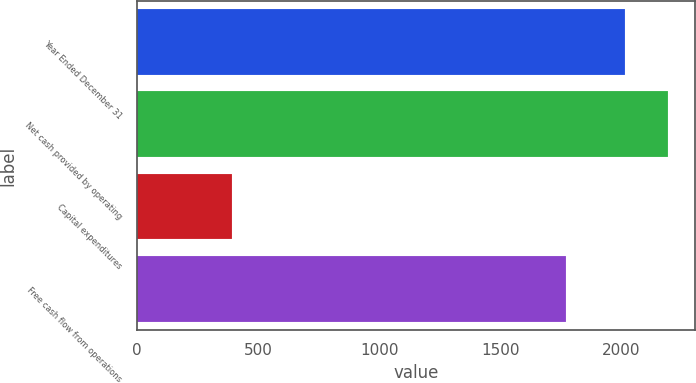<chart> <loc_0><loc_0><loc_500><loc_500><bar_chart><fcel>Year Ended December 31<fcel>Net cash provided by operating<fcel>Capital expenditures<fcel>Free cash flow from operations<nl><fcel>2016<fcel>2193.1<fcel>392<fcel>1771<nl></chart> 